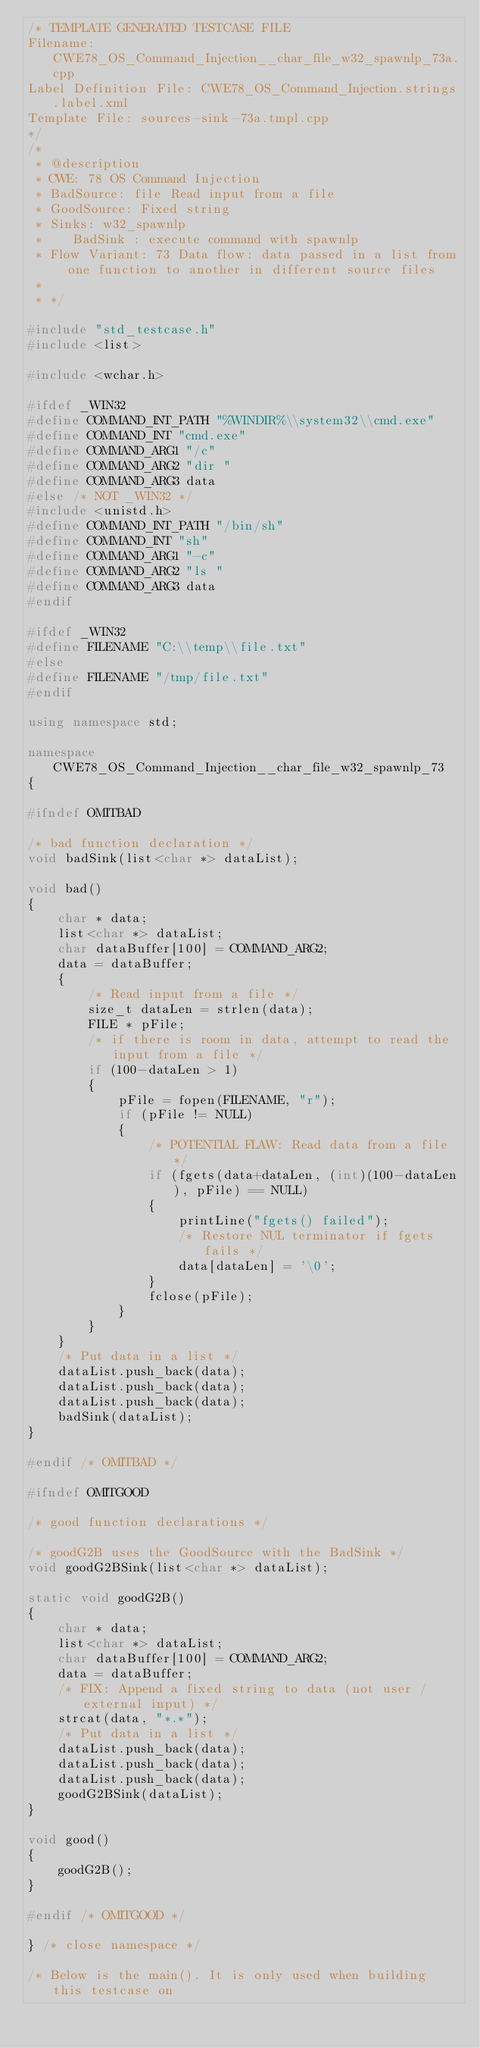Convert code to text. <code><loc_0><loc_0><loc_500><loc_500><_C++_>/* TEMPLATE GENERATED TESTCASE FILE
Filename: CWE78_OS_Command_Injection__char_file_w32_spawnlp_73a.cpp
Label Definition File: CWE78_OS_Command_Injection.strings.label.xml
Template File: sources-sink-73a.tmpl.cpp
*/
/*
 * @description
 * CWE: 78 OS Command Injection
 * BadSource: file Read input from a file
 * GoodSource: Fixed string
 * Sinks: w32_spawnlp
 *    BadSink : execute command with spawnlp
 * Flow Variant: 73 Data flow: data passed in a list from one function to another in different source files
 *
 * */

#include "std_testcase.h"
#include <list>

#include <wchar.h>

#ifdef _WIN32
#define COMMAND_INT_PATH "%WINDIR%\\system32\\cmd.exe"
#define COMMAND_INT "cmd.exe"
#define COMMAND_ARG1 "/c"
#define COMMAND_ARG2 "dir "
#define COMMAND_ARG3 data
#else /* NOT _WIN32 */
#include <unistd.h>
#define COMMAND_INT_PATH "/bin/sh"
#define COMMAND_INT "sh"
#define COMMAND_ARG1 "-c"
#define COMMAND_ARG2 "ls "
#define COMMAND_ARG3 data
#endif

#ifdef _WIN32
#define FILENAME "C:\\temp\\file.txt"
#else
#define FILENAME "/tmp/file.txt"
#endif

using namespace std;

namespace CWE78_OS_Command_Injection__char_file_w32_spawnlp_73
{

#ifndef OMITBAD

/* bad function declaration */
void badSink(list<char *> dataList);

void bad()
{
    char * data;
    list<char *> dataList;
    char dataBuffer[100] = COMMAND_ARG2;
    data = dataBuffer;
    {
        /* Read input from a file */
        size_t dataLen = strlen(data);
        FILE * pFile;
        /* if there is room in data, attempt to read the input from a file */
        if (100-dataLen > 1)
        {
            pFile = fopen(FILENAME, "r");
            if (pFile != NULL)
            {
                /* POTENTIAL FLAW: Read data from a file */
                if (fgets(data+dataLen, (int)(100-dataLen), pFile) == NULL)
                {
                    printLine("fgets() failed");
                    /* Restore NUL terminator if fgets fails */
                    data[dataLen] = '\0';
                }
                fclose(pFile);
            }
        }
    }
    /* Put data in a list */
    dataList.push_back(data);
    dataList.push_back(data);
    dataList.push_back(data);
    badSink(dataList);
}

#endif /* OMITBAD */

#ifndef OMITGOOD

/* good function declarations */

/* goodG2B uses the GoodSource with the BadSink */
void goodG2BSink(list<char *> dataList);

static void goodG2B()
{
    char * data;
    list<char *> dataList;
    char dataBuffer[100] = COMMAND_ARG2;
    data = dataBuffer;
    /* FIX: Append a fixed string to data (not user / external input) */
    strcat(data, "*.*");
    /* Put data in a list */
    dataList.push_back(data);
    dataList.push_back(data);
    dataList.push_back(data);
    goodG2BSink(dataList);
}

void good()
{
    goodG2B();
}

#endif /* OMITGOOD */

} /* close namespace */

/* Below is the main(). It is only used when building this testcase on</code> 